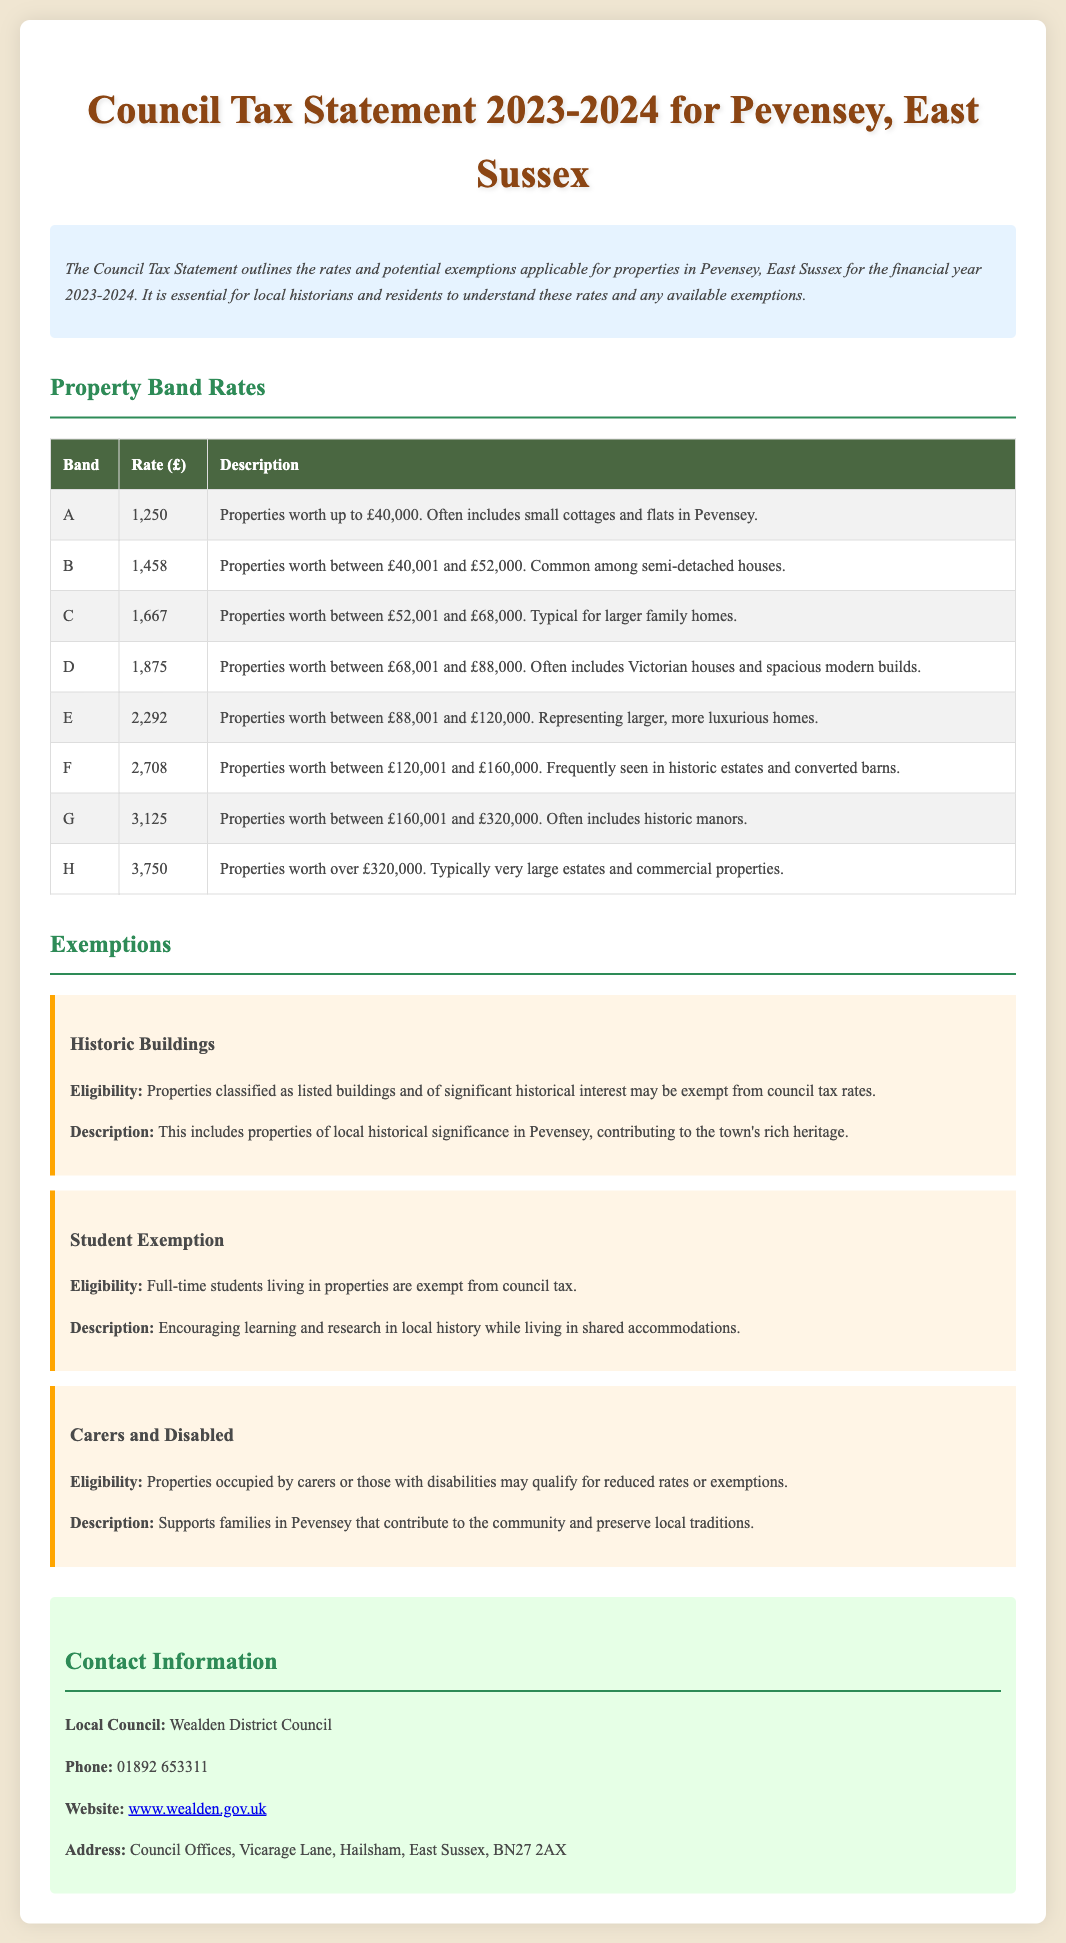What is the council tax rate for Band A? The council tax rate for Band A is explicitly stated in the table as £1,250.
Answer: £1,250 What properties fall under Band C? Band C includes properties worth between £52,001 and £68,000, typical for larger family homes.
Answer: Larger family homes What type of properties may be exempt from council tax due to historical significance? The document states that properties classified as listed buildings and of significant historical interest may qualify for exemption.
Answer: Listed buildings What is the exemption for full-time students? The document mentions that full-time students living in properties are exempt from council tax.
Answer: Exempt from council tax Which organization can be contacted regarding council tax inquiries? The contact information provided indicates that Wealden District Council can be contacted for inquiries.
Answer: Wealden District Council What is the rate for Band G properties? The document specifies the rate for Band G properties as £3,125.
Answer: £3,125 How does the document describe the exemptions for disability? The document describes reduced rates or exemptions for properties occupied by carers or those with disabilities.
Answer: Reduced rates or exemptions What financial year does this council tax statement cover? The statement clearly indicates it covers the financial year 2023-2024.
Answer: 2023-2024 